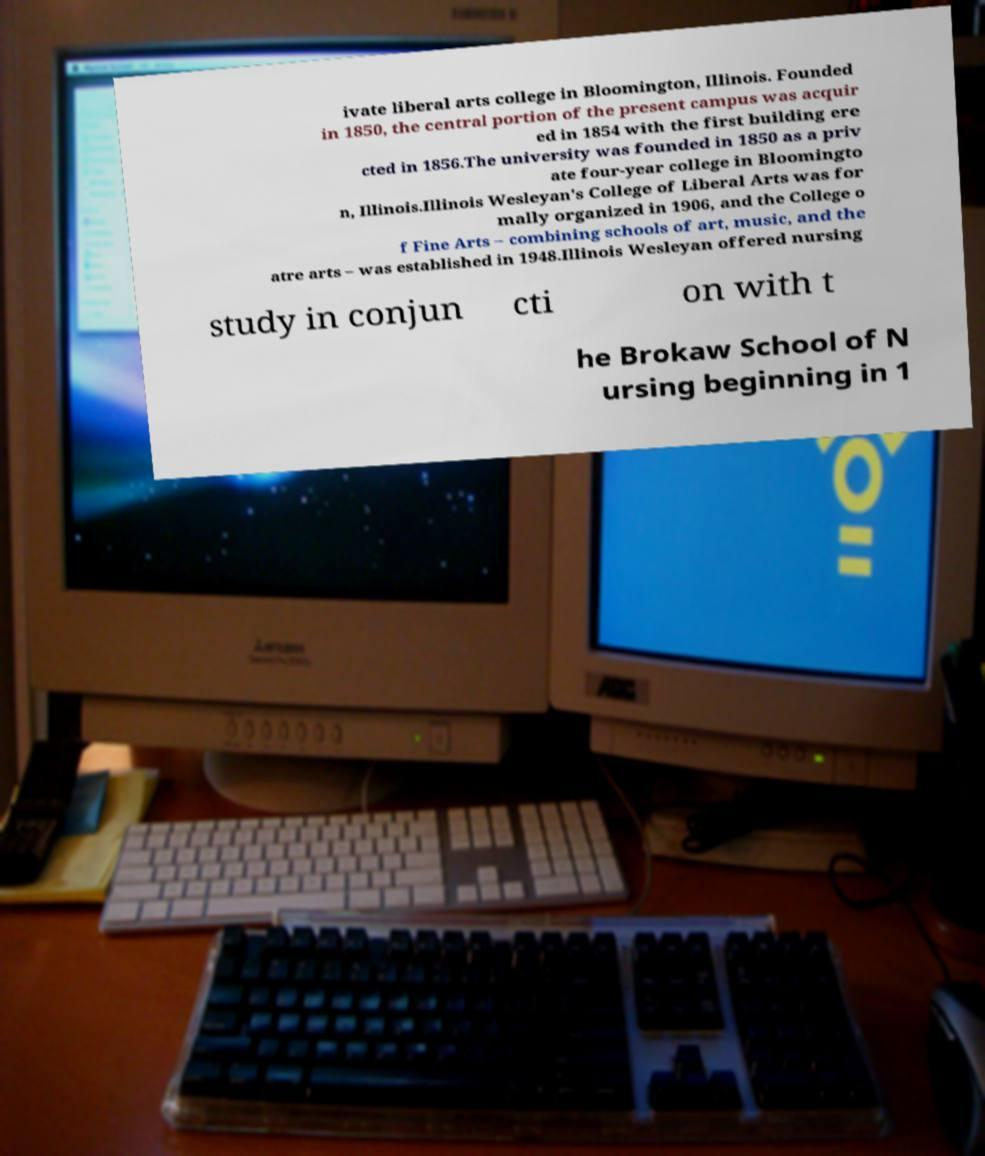Please identify and transcribe the text found in this image. ivate liberal arts college in Bloomington, Illinois. Founded in 1850, the central portion of the present campus was acquir ed in 1854 with the first building ere cted in 1856.The university was founded in 1850 as a priv ate four-year college in Bloomingto n, Illinois.Illinois Wesleyan's College of Liberal Arts was for mally organized in 1906, and the College o f Fine Arts – combining schools of art, music, and the atre arts – was established in 1948.Illinois Wesleyan offered nursing study in conjun cti on with t he Brokaw School of N ursing beginning in 1 